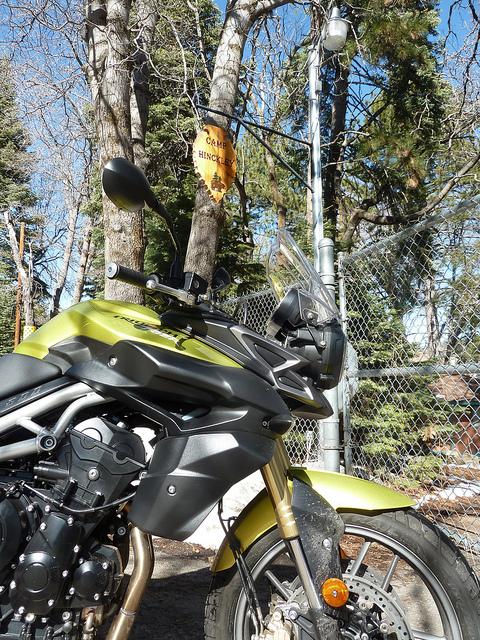Why are the trees bare?
Answer briefly. Autumn. Is this a sunny day?
Answer briefly. Yes. What is parked in front of the fence?
Quick response, please. Motorcycle. 